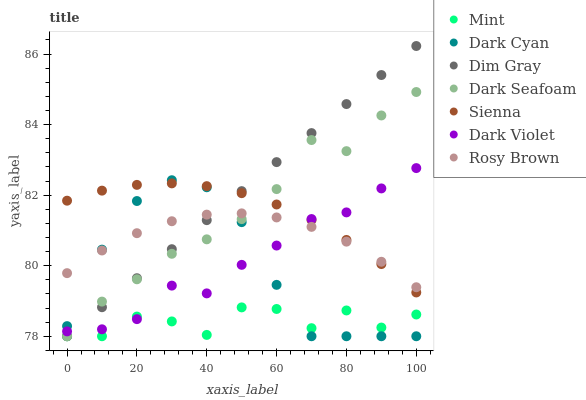Does Mint have the minimum area under the curve?
Answer yes or no. Yes. Does Dim Gray have the maximum area under the curve?
Answer yes or no. Yes. Does Rosy Brown have the minimum area under the curve?
Answer yes or no. No. Does Rosy Brown have the maximum area under the curve?
Answer yes or no. No. Is Dim Gray the smoothest?
Answer yes or no. Yes. Is Mint the roughest?
Answer yes or no. Yes. Is Rosy Brown the smoothest?
Answer yes or no. No. Is Rosy Brown the roughest?
Answer yes or no. No. Does Dim Gray have the lowest value?
Answer yes or no. Yes. Does Dark Violet have the lowest value?
Answer yes or no. No. Does Dim Gray have the highest value?
Answer yes or no. Yes. Does Rosy Brown have the highest value?
Answer yes or no. No. Is Mint less than Sienna?
Answer yes or no. Yes. Is Sienna greater than Mint?
Answer yes or no. Yes. Does Rosy Brown intersect Dim Gray?
Answer yes or no. Yes. Is Rosy Brown less than Dim Gray?
Answer yes or no. No. Is Rosy Brown greater than Dim Gray?
Answer yes or no. No. Does Mint intersect Sienna?
Answer yes or no. No. 